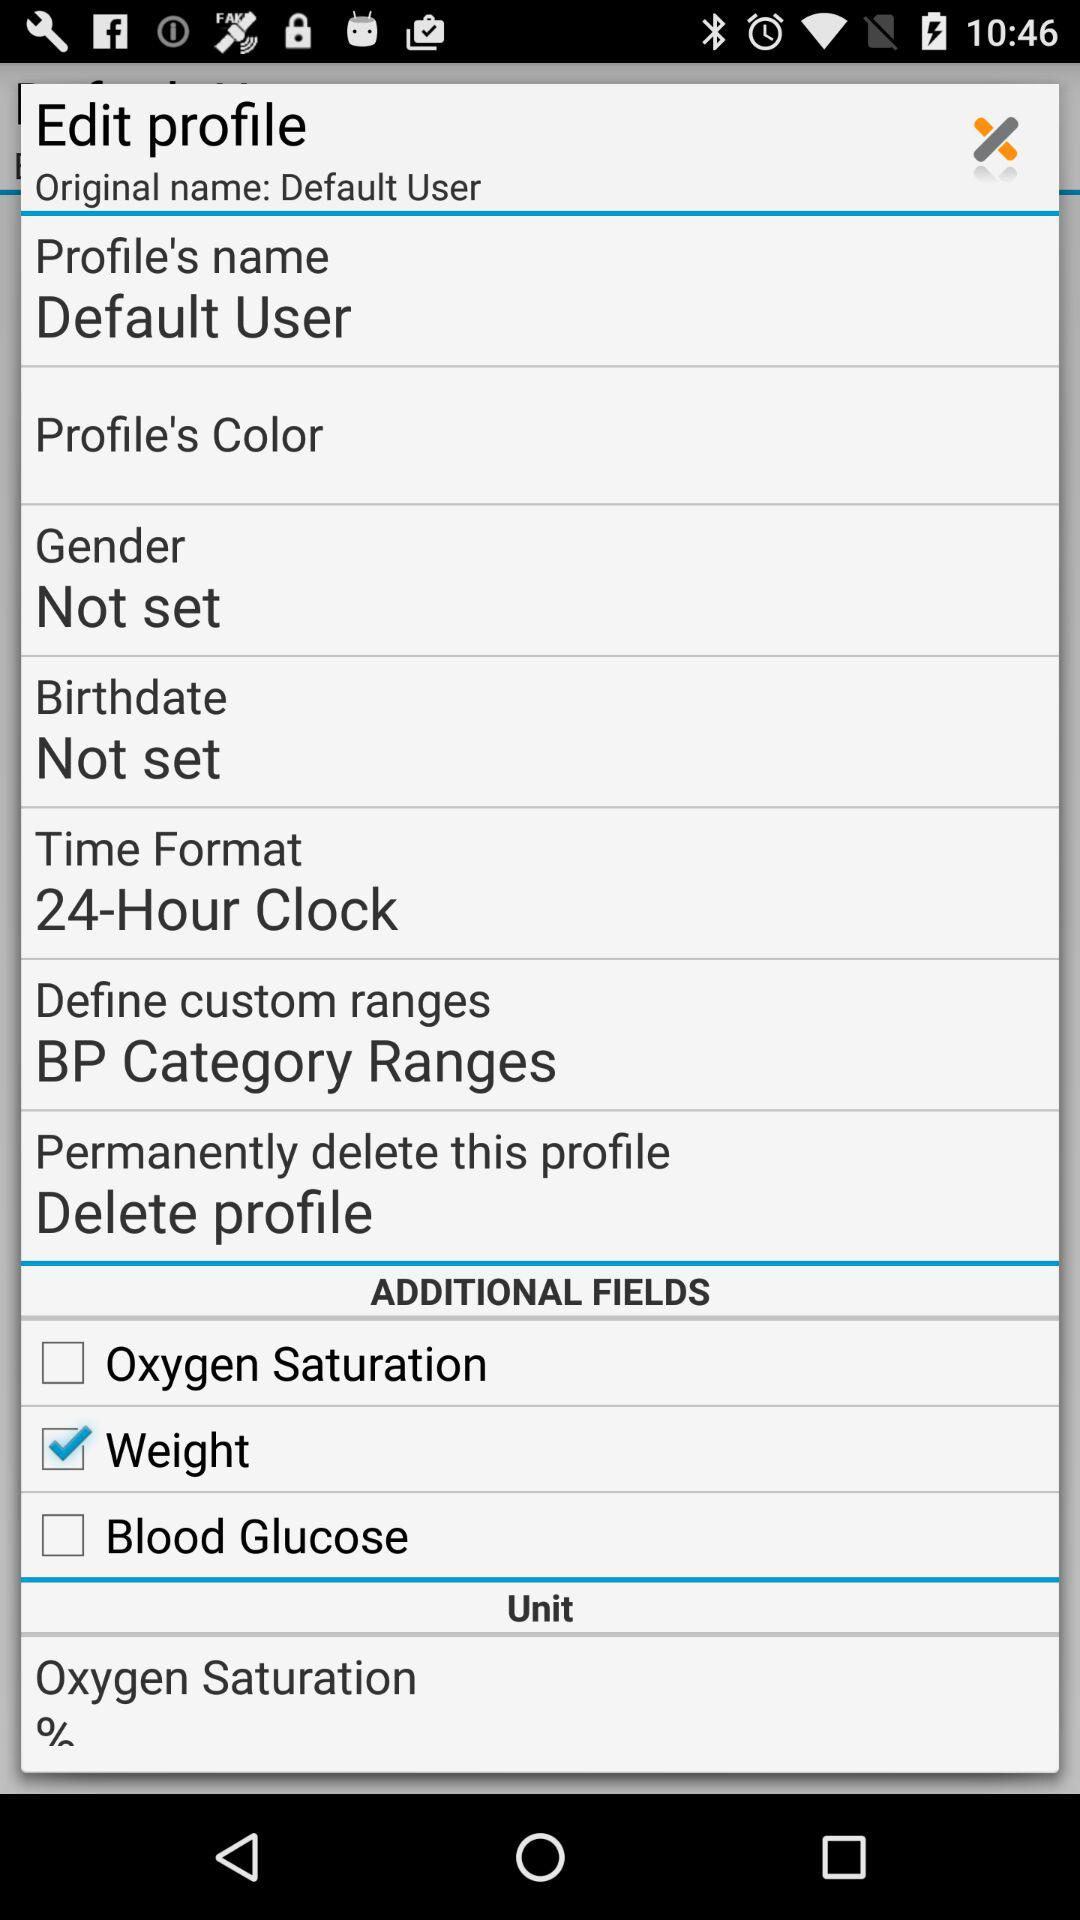What is the "Define custom ranges"? "Define custom ranges" is BP Category Ranges. 